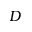<formula> <loc_0><loc_0><loc_500><loc_500>D</formula> 